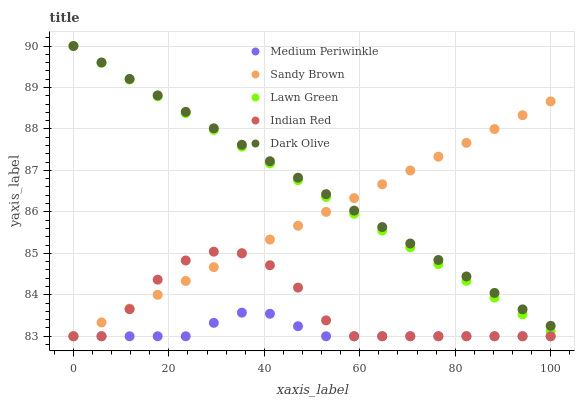Does Medium Periwinkle have the minimum area under the curve?
Answer yes or no. Yes. Does Dark Olive have the maximum area under the curve?
Answer yes or no. Yes. Does Dark Olive have the minimum area under the curve?
Answer yes or no. No. Does Medium Periwinkle have the maximum area under the curve?
Answer yes or no. No. Is Sandy Brown the smoothest?
Answer yes or no. Yes. Is Indian Red the roughest?
Answer yes or no. Yes. Is Dark Olive the smoothest?
Answer yes or no. No. Is Dark Olive the roughest?
Answer yes or no. No. Does Sandy Brown have the lowest value?
Answer yes or no. Yes. Does Dark Olive have the lowest value?
Answer yes or no. No. Does Lawn Green have the highest value?
Answer yes or no. Yes. Does Medium Periwinkle have the highest value?
Answer yes or no. No. Is Medium Periwinkle less than Dark Olive?
Answer yes or no. Yes. Is Dark Olive greater than Indian Red?
Answer yes or no. Yes. Does Lawn Green intersect Sandy Brown?
Answer yes or no. Yes. Is Lawn Green less than Sandy Brown?
Answer yes or no. No. Is Lawn Green greater than Sandy Brown?
Answer yes or no. No. Does Medium Periwinkle intersect Dark Olive?
Answer yes or no. No. 